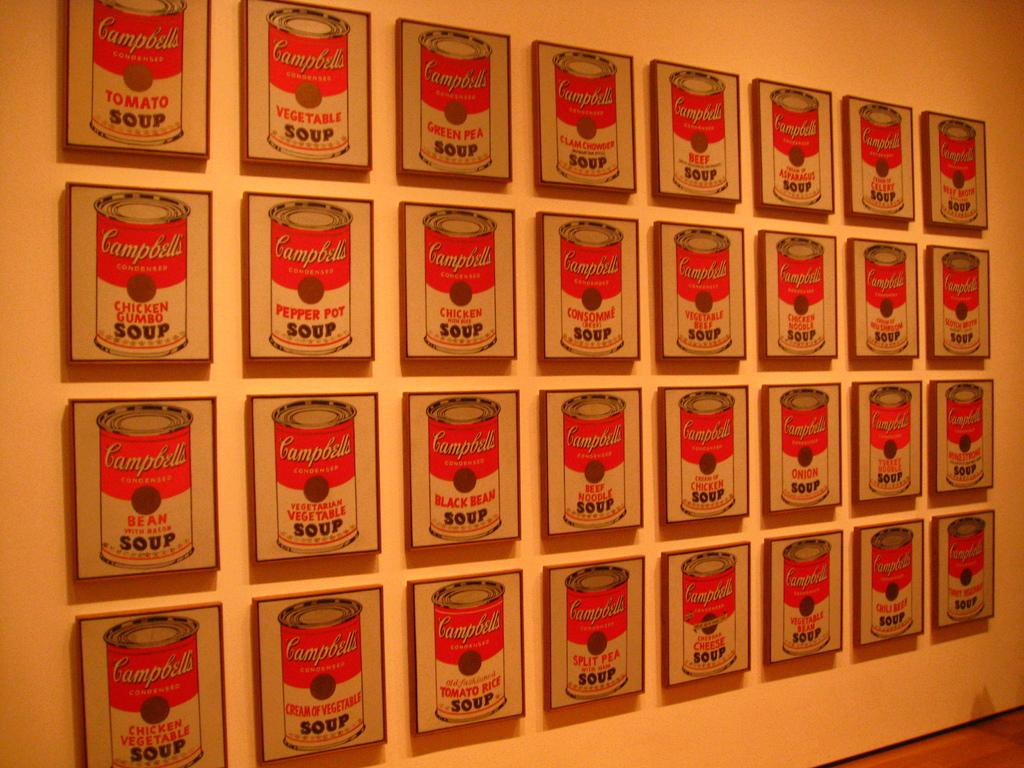What is hanging on the wall in the image? There are frames on the wall in the image. What type of pie is being served in the image? There is no pie present in the image; it only features frames on the wall. What is the weather like in the image? The provided facts do not mention any information about the weather, so it cannot be determined from the image. 